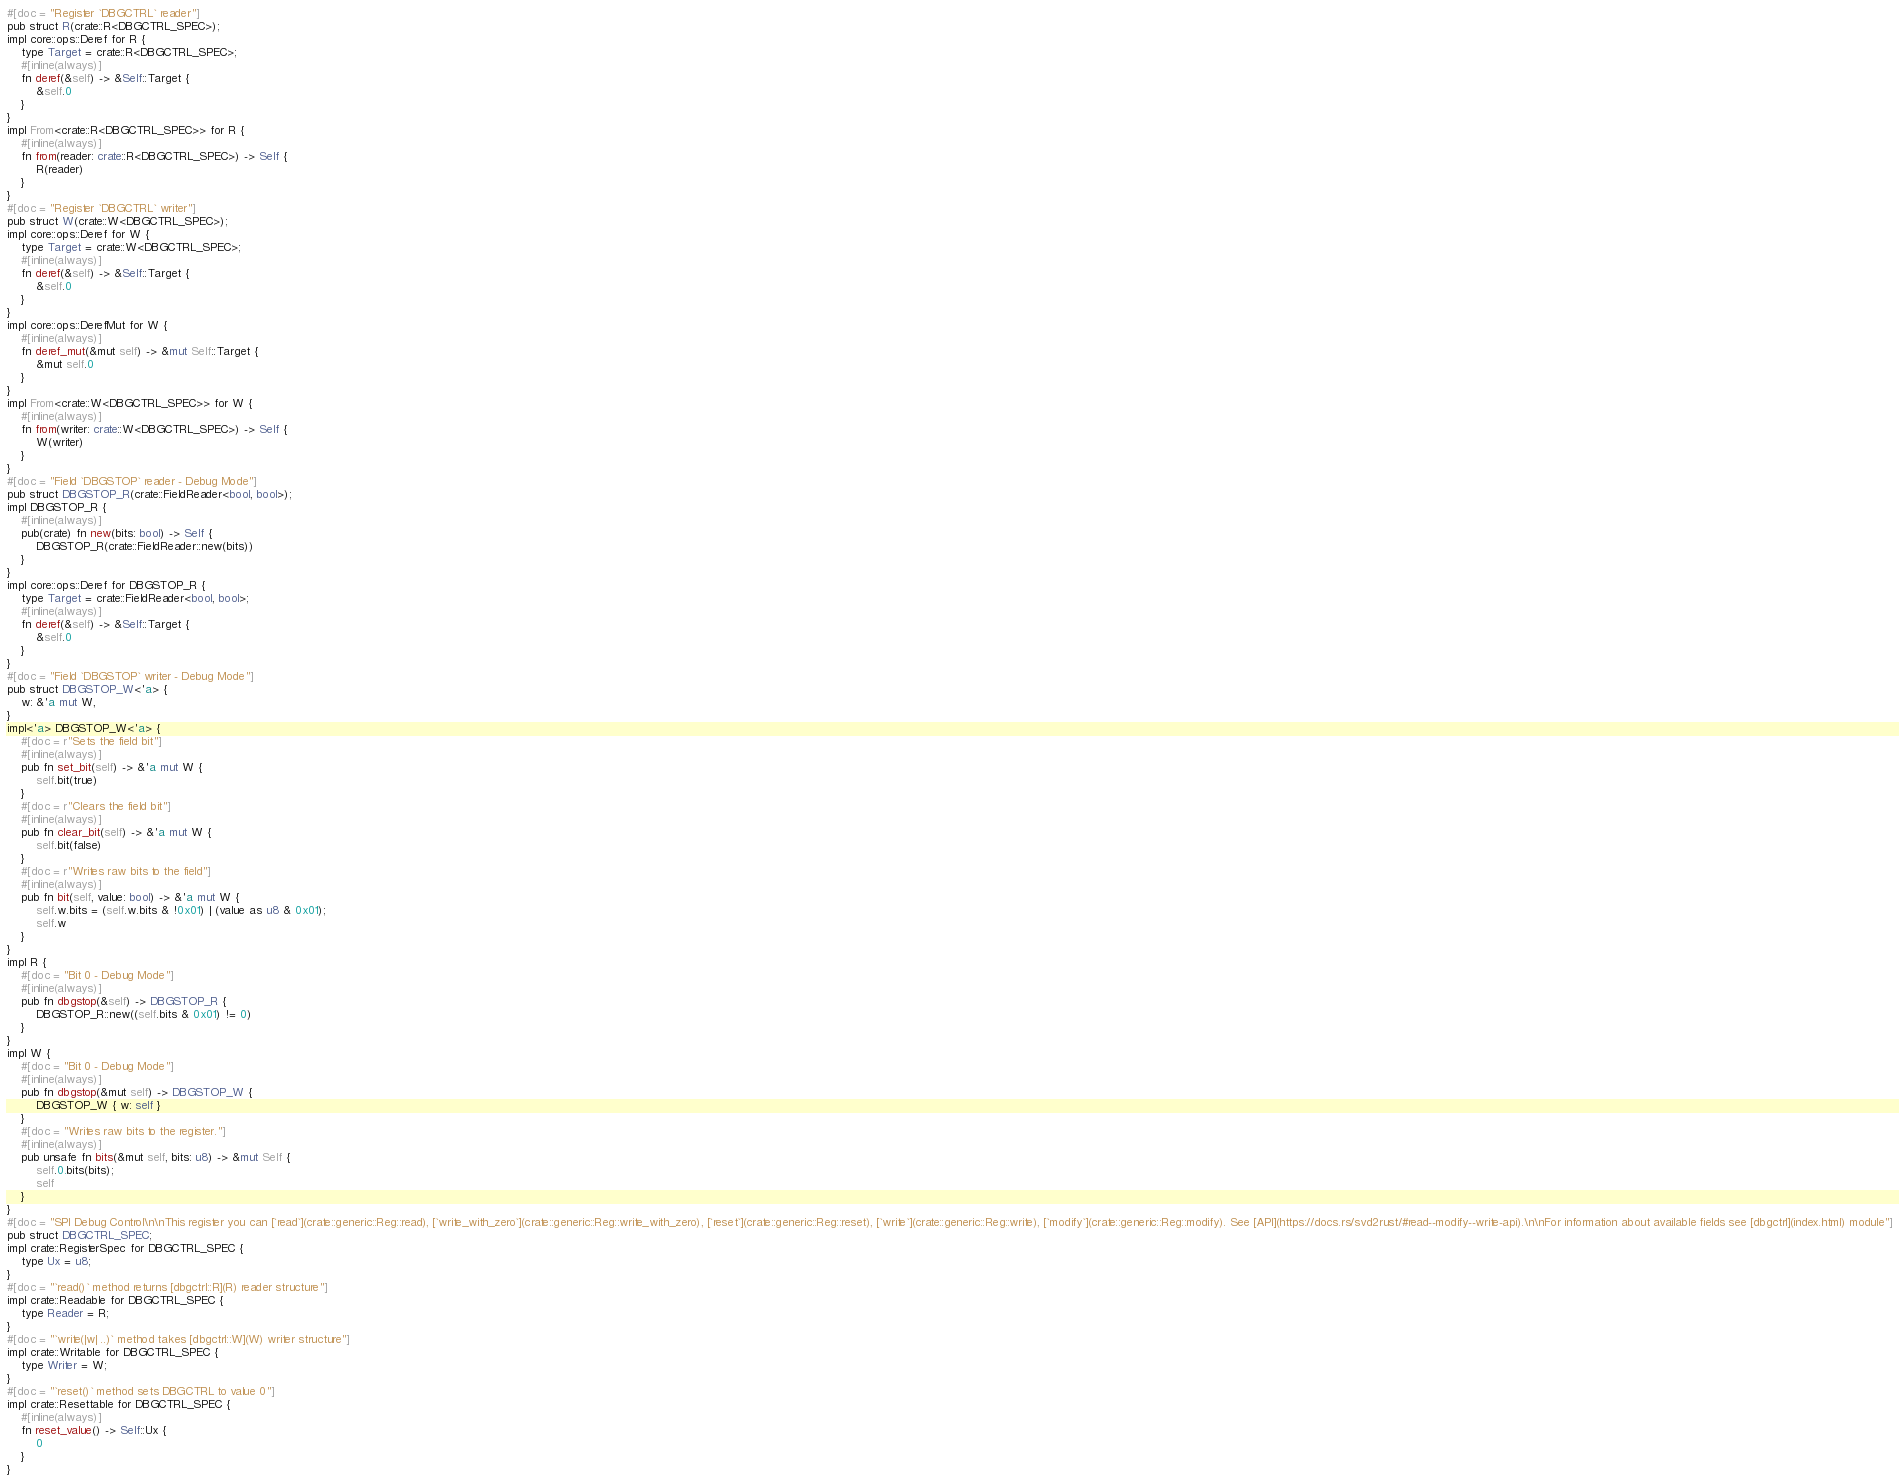Convert code to text. <code><loc_0><loc_0><loc_500><loc_500><_Rust_>#[doc = "Register `DBGCTRL` reader"]
pub struct R(crate::R<DBGCTRL_SPEC>);
impl core::ops::Deref for R {
    type Target = crate::R<DBGCTRL_SPEC>;
    #[inline(always)]
    fn deref(&self) -> &Self::Target {
        &self.0
    }
}
impl From<crate::R<DBGCTRL_SPEC>> for R {
    #[inline(always)]
    fn from(reader: crate::R<DBGCTRL_SPEC>) -> Self {
        R(reader)
    }
}
#[doc = "Register `DBGCTRL` writer"]
pub struct W(crate::W<DBGCTRL_SPEC>);
impl core::ops::Deref for W {
    type Target = crate::W<DBGCTRL_SPEC>;
    #[inline(always)]
    fn deref(&self) -> &Self::Target {
        &self.0
    }
}
impl core::ops::DerefMut for W {
    #[inline(always)]
    fn deref_mut(&mut self) -> &mut Self::Target {
        &mut self.0
    }
}
impl From<crate::W<DBGCTRL_SPEC>> for W {
    #[inline(always)]
    fn from(writer: crate::W<DBGCTRL_SPEC>) -> Self {
        W(writer)
    }
}
#[doc = "Field `DBGSTOP` reader - Debug Mode"]
pub struct DBGSTOP_R(crate::FieldReader<bool, bool>);
impl DBGSTOP_R {
    #[inline(always)]
    pub(crate) fn new(bits: bool) -> Self {
        DBGSTOP_R(crate::FieldReader::new(bits))
    }
}
impl core::ops::Deref for DBGSTOP_R {
    type Target = crate::FieldReader<bool, bool>;
    #[inline(always)]
    fn deref(&self) -> &Self::Target {
        &self.0
    }
}
#[doc = "Field `DBGSTOP` writer - Debug Mode"]
pub struct DBGSTOP_W<'a> {
    w: &'a mut W,
}
impl<'a> DBGSTOP_W<'a> {
    #[doc = r"Sets the field bit"]
    #[inline(always)]
    pub fn set_bit(self) -> &'a mut W {
        self.bit(true)
    }
    #[doc = r"Clears the field bit"]
    #[inline(always)]
    pub fn clear_bit(self) -> &'a mut W {
        self.bit(false)
    }
    #[doc = r"Writes raw bits to the field"]
    #[inline(always)]
    pub fn bit(self, value: bool) -> &'a mut W {
        self.w.bits = (self.w.bits & !0x01) | (value as u8 & 0x01);
        self.w
    }
}
impl R {
    #[doc = "Bit 0 - Debug Mode"]
    #[inline(always)]
    pub fn dbgstop(&self) -> DBGSTOP_R {
        DBGSTOP_R::new((self.bits & 0x01) != 0)
    }
}
impl W {
    #[doc = "Bit 0 - Debug Mode"]
    #[inline(always)]
    pub fn dbgstop(&mut self) -> DBGSTOP_W {
        DBGSTOP_W { w: self }
    }
    #[doc = "Writes raw bits to the register."]
    #[inline(always)]
    pub unsafe fn bits(&mut self, bits: u8) -> &mut Self {
        self.0.bits(bits);
        self
    }
}
#[doc = "SPI Debug Control\n\nThis register you can [`read`](crate::generic::Reg::read), [`write_with_zero`](crate::generic::Reg::write_with_zero), [`reset`](crate::generic::Reg::reset), [`write`](crate::generic::Reg::write), [`modify`](crate::generic::Reg::modify). See [API](https://docs.rs/svd2rust/#read--modify--write-api).\n\nFor information about available fields see [dbgctrl](index.html) module"]
pub struct DBGCTRL_SPEC;
impl crate::RegisterSpec for DBGCTRL_SPEC {
    type Ux = u8;
}
#[doc = "`read()` method returns [dbgctrl::R](R) reader structure"]
impl crate::Readable for DBGCTRL_SPEC {
    type Reader = R;
}
#[doc = "`write(|w| ..)` method takes [dbgctrl::W](W) writer structure"]
impl crate::Writable for DBGCTRL_SPEC {
    type Writer = W;
}
#[doc = "`reset()` method sets DBGCTRL to value 0"]
impl crate::Resettable for DBGCTRL_SPEC {
    #[inline(always)]
    fn reset_value() -> Self::Ux {
        0
    }
}
</code> 